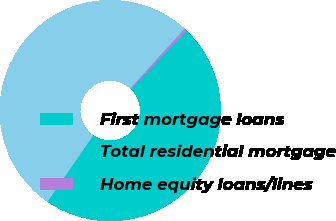Convert chart. <chart><loc_0><loc_0><loc_500><loc_500><pie_chart><fcel>First mortgage loans<fcel>Total residential mortgage<fcel>Home equity loans/lines<nl><fcel>47.43%<fcel>52.14%<fcel>0.43%<nl></chart> 